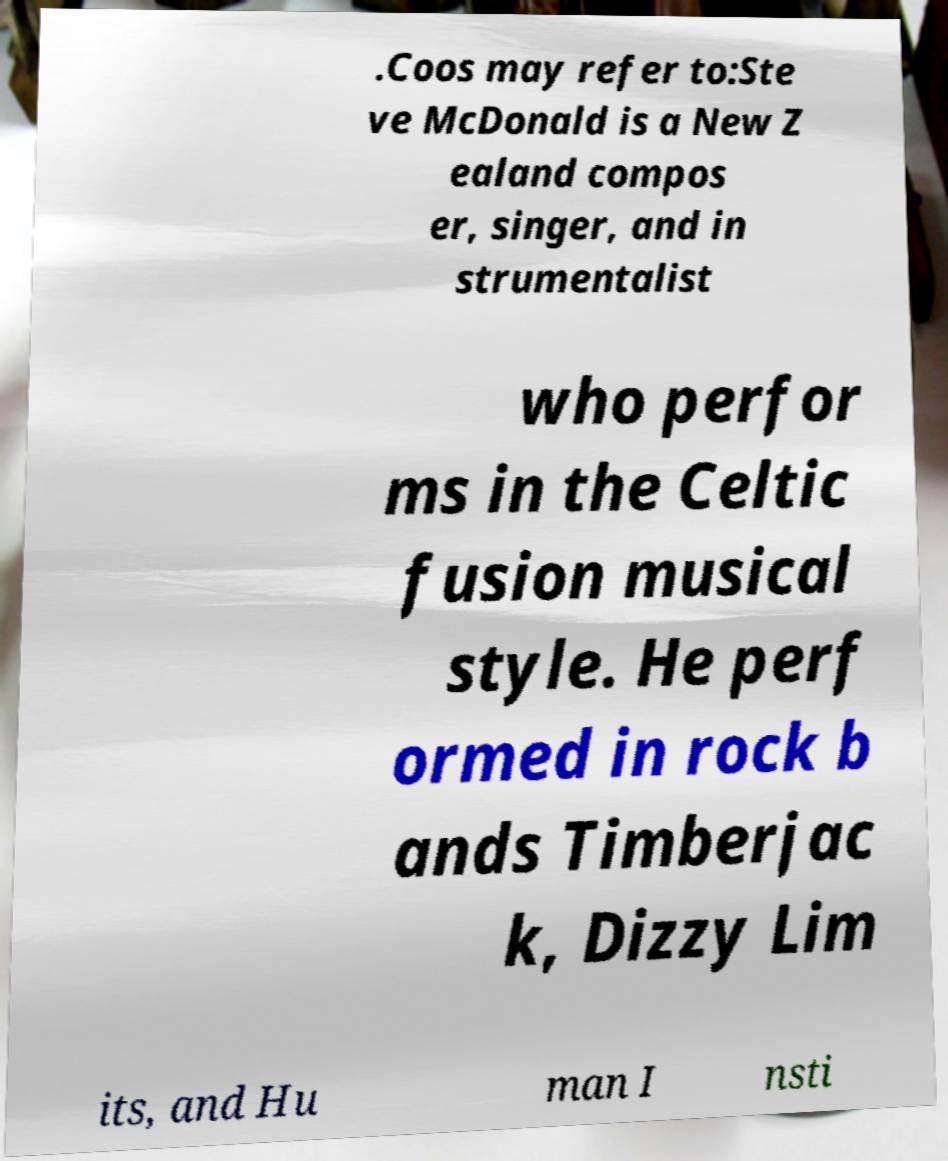Could you extract and type out the text from this image? .Coos may refer to:Ste ve McDonald is a New Z ealand compos er, singer, and in strumentalist who perfor ms in the Celtic fusion musical style. He perf ormed in rock b ands Timberjac k, Dizzy Lim its, and Hu man I nsti 